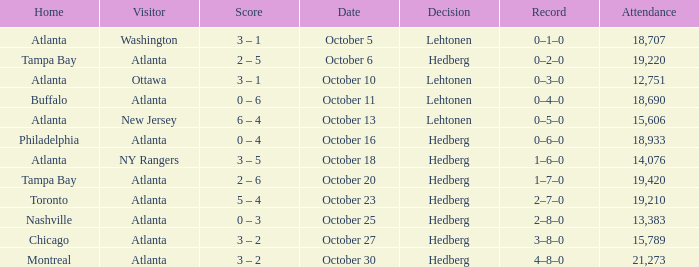What was the record on the game that was played on october 27? 3–8–0. 